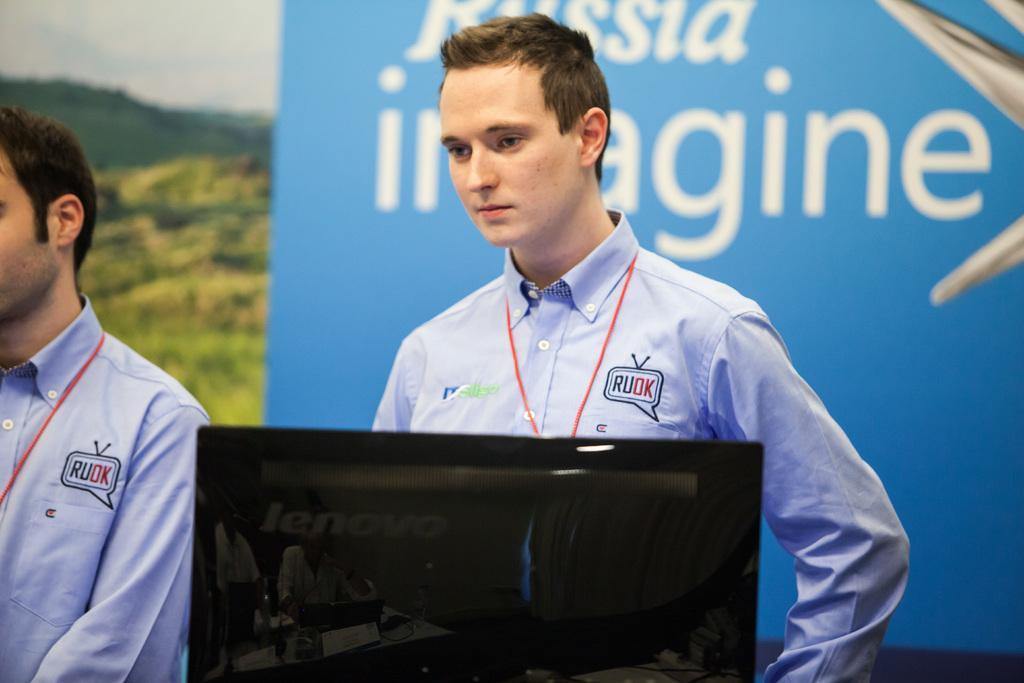Could you give a brief overview of what you see in this image? In this image we can see two persons standing, in front of them there is a monitor. In the background there is a banner, trees, mountains and sky. 